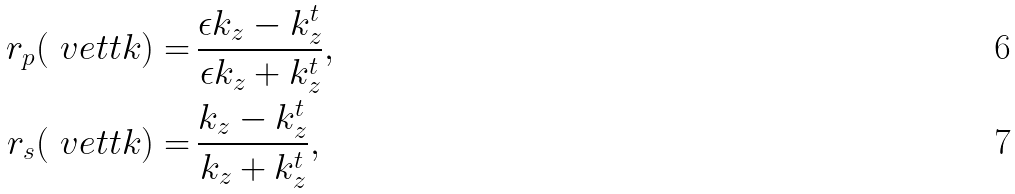<formula> <loc_0><loc_0><loc_500><loc_500>r _ { p } ( \ v e t t { k } ) = & \, \frac { \epsilon k _ { z } - k _ { z } ^ { t } } { \epsilon k _ { z } + k _ { z } ^ { t } } , \\ r _ { s } ( \ v e t t { k } ) = & \, \frac { k _ { z } - k _ { z } ^ { t } } { k _ { z } + k _ { z } ^ { t } } ,</formula> 